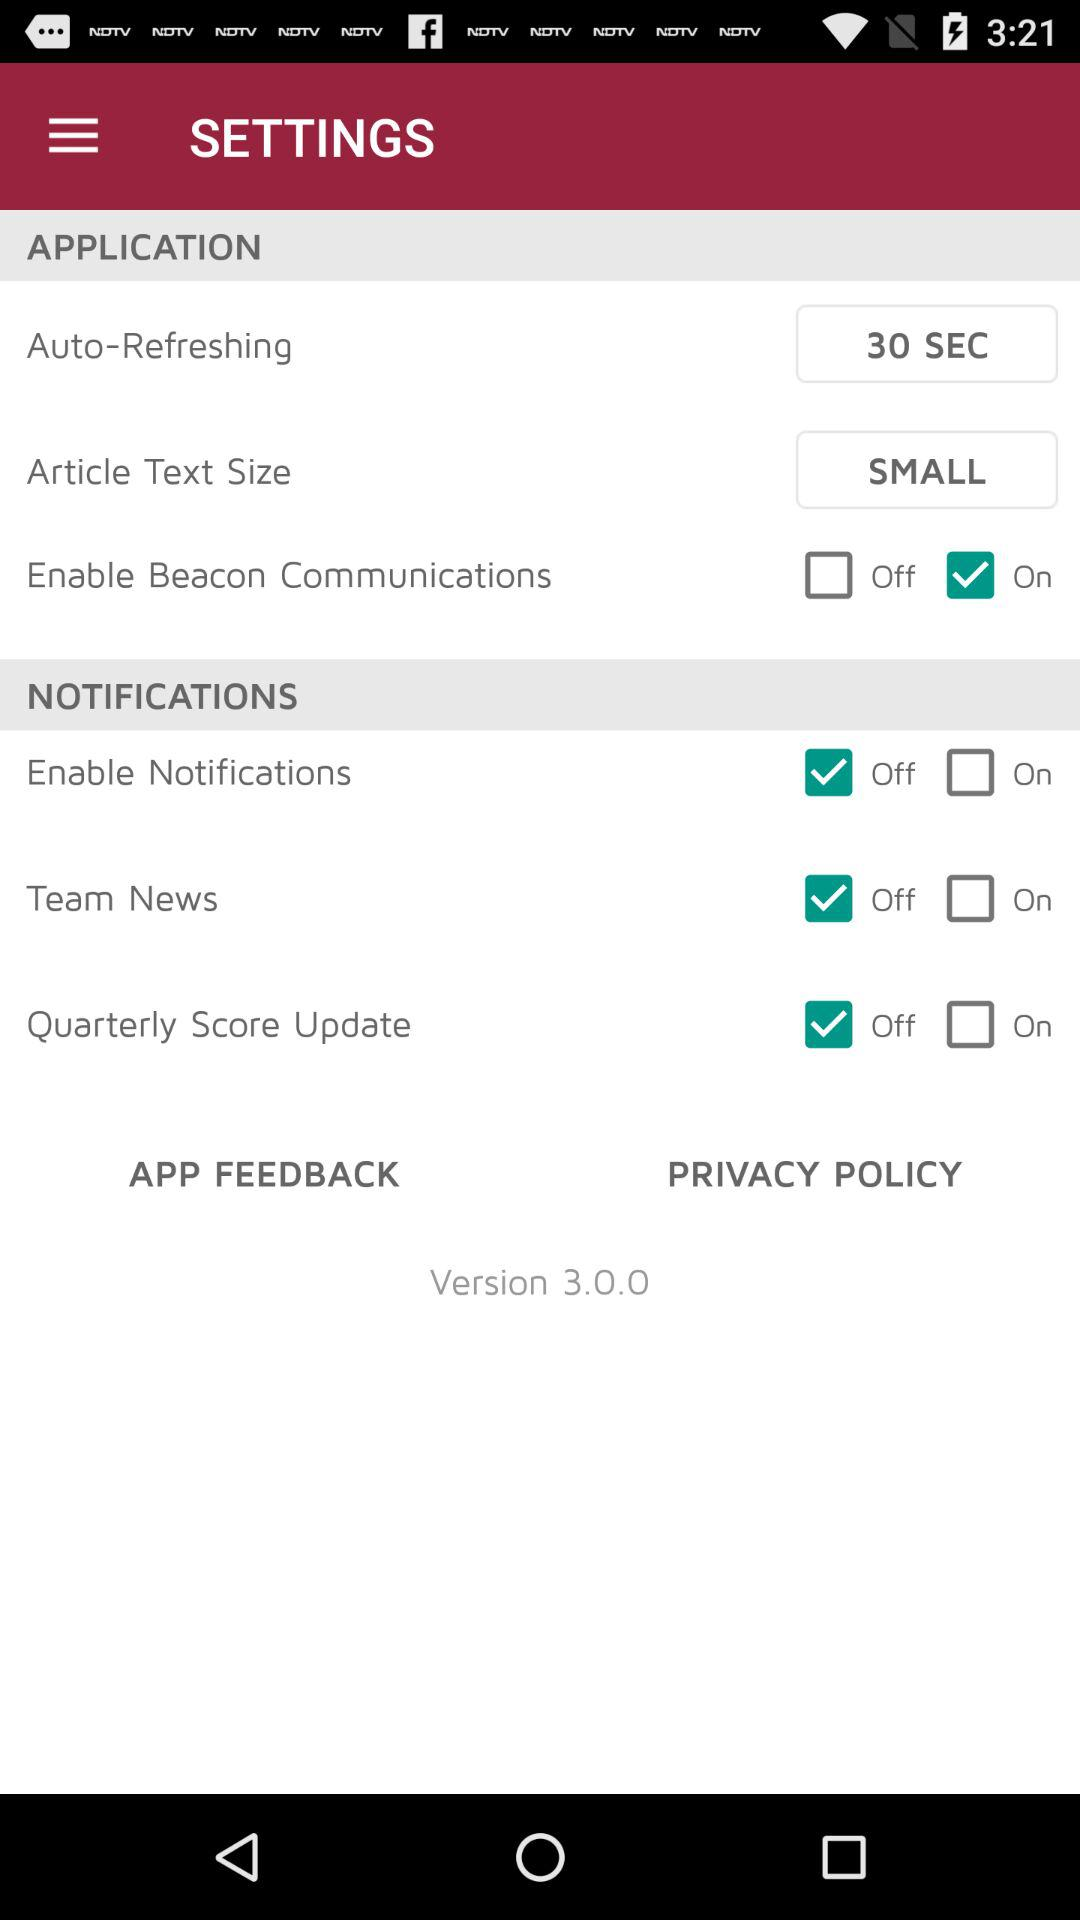Which email will team news be sent to?
When the provided information is insufficient, respond with <no answer>. <no answer> 